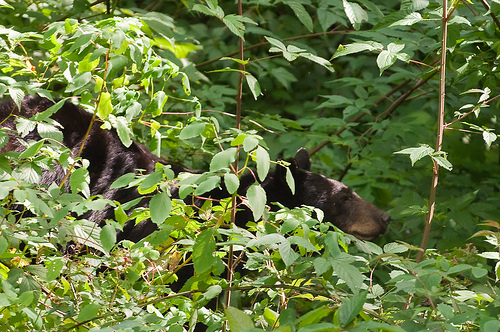<image>
Is the bear in front of the plant? No. The bear is not in front of the plant. The spatial positioning shows a different relationship between these objects. 